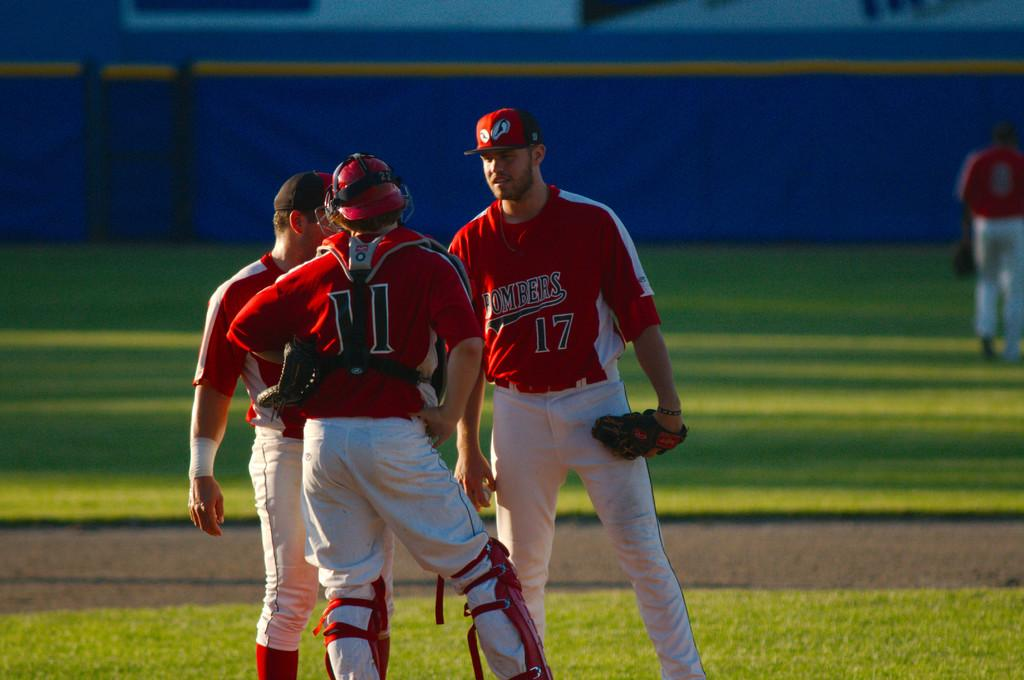<image>
Render a clear and concise summary of the photo. Three baseball players are standing on the field with ed tops and white bottoms including numbers 11 and 17. 